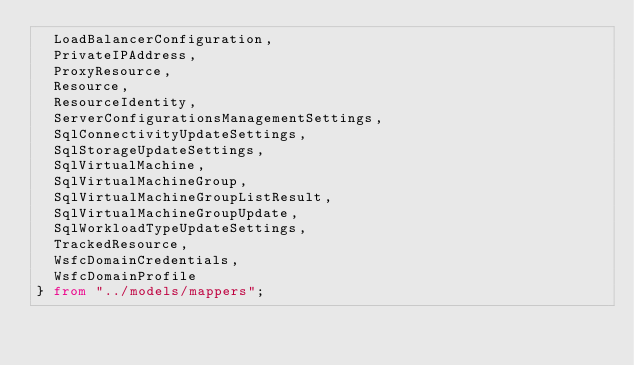Convert code to text. <code><loc_0><loc_0><loc_500><loc_500><_TypeScript_>  LoadBalancerConfiguration,
  PrivateIPAddress,
  ProxyResource,
  Resource,
  ResourceIdentity,
  ServerConfigurationsManagementSettings,
  SqlConnectivityUpdateSettings,
  SqlStorageUpdateSettings,
  SqlVirtualMachine,
  SqlVirtualMachineGroup,
  SqlVirtualMachineGroupListResult,
  SqlVirtualMachineGroupUpdate,
  SqlWorkloadTypeUpdateSettings,
  TrackedResource,
  WsfcDomainCredentials,
  WsfcDomainProfile
} from "../models/mappers";
</code> 